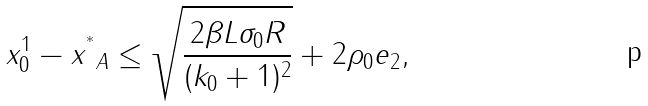<formula> <loc_0><loc_0><loc_500><loc_500>\| x _ { 0 } ^ { 1 } - x ^ { ^ { * } } \| _ { A } \leq \sqrt { \frac { 2 \beta L \sigma _ { 0 } R } { ( k _ { 0 } + 1 ) ^ { 2 } } } + 2 \rho _ { 0 } \| e \| _ { 2 } ,</formula> 